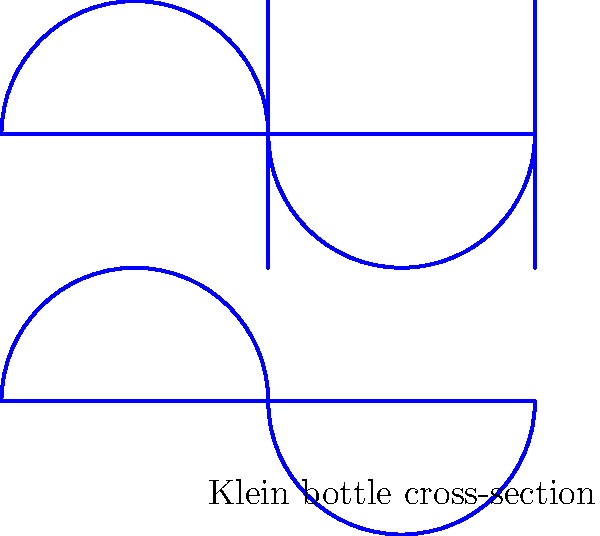In designing an innovative interior space inspired by non-Euclidean geometry, you decide to incorporate elements reminiscent of a Klein bottle. Given the cross-section of a Klein bottle shown above, what unique property of this shape could be leveraged to create an intriguing spatial experience, and how might it challenge traditional notions of interior and exterior spaces? To answer this question, let's examine the properties of a Klein bottle and their implications for architectural design:

1. Topology: A Klein bottle is a non-orientable surface with no inside or outside. It's a closed surface with no boundary.

2. Cross-section: The diagram shows a cross-section of a Klein bottle, which appears as two circles connected by "passages."

3. Continuity: In a Klein bottle, the inside surface transitions seamlessly to the outside surface without crossing an edge.

4. Dimensional representation: While a true Klein bottle exists in 4D space, we can represent it in 3D with self-intersections.

5. Architectural implications:
   a) Challenging interior/exterior dichotomy: Spaces could be designed to blur the distinction between inside and outside.
   b) Continuous flow: Create areas that seamlessly transition from one space to another without clear boundaries.
   c) Spatial illusions: Use the Klein bottle's properties to create optical illusions and unexpected spatial relationships.
   d) Innovative circulation: Design circulation paths that seem to "invert" as one moves through the space.

6. Practical applications:
   a) Create interconnected rooms that loop back on themselves in unexpected ways.
   b) Design facades that seem to fold into interior spaces and vice versa.
   c) Implement lighting and material treatments that enhance the sense of continuous, flowing space.

By leveraging the Klein bottle's unique properties, an architect can create spaces that challenge conventional perceptions of enclosure and continuity, offering a truly innovative and thought-provoking spatial experience.
Answer: Continuous surface without inside/outside distinction, enabling seamless spatial transitions and challenging traditional interior/exterior boundaries. 